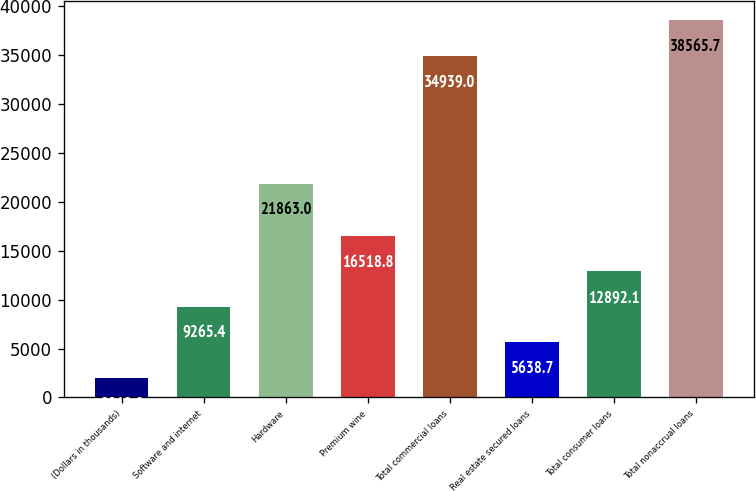Convert chart. <chart><loc_0><loc_0><loc_500><loc_500><bar_chart><fcel>(Dollars in thousands)<fcel>Software and internet<fcel>Hardware<fcel>Premium wine<fcel>Total commercial loans<fcel>Real estate secured loans<fcel>Total consumer loans<fcel>Total nonaccrual loans<nl><fcel>2012<fcel>9265.4<fcel>21863<fcel>16518.8<fcel>34939<fcel>5638.7<fcel>12892.1<fcel>38565.7<nl></chart> 